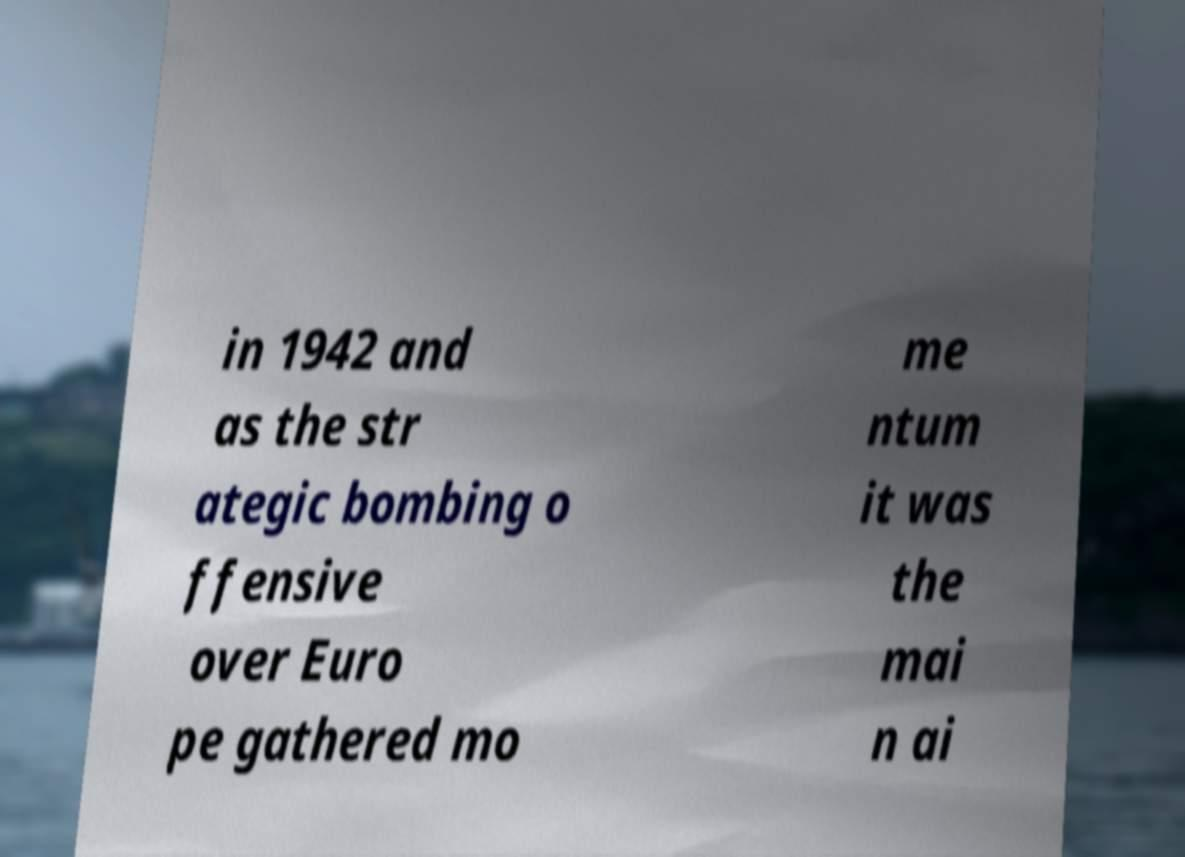Please identify and transcribe the text found in this image. in 1942 and as the str ategic bombing o ffensive over Euro pe gathered mo me ntum it was the mai n ai 